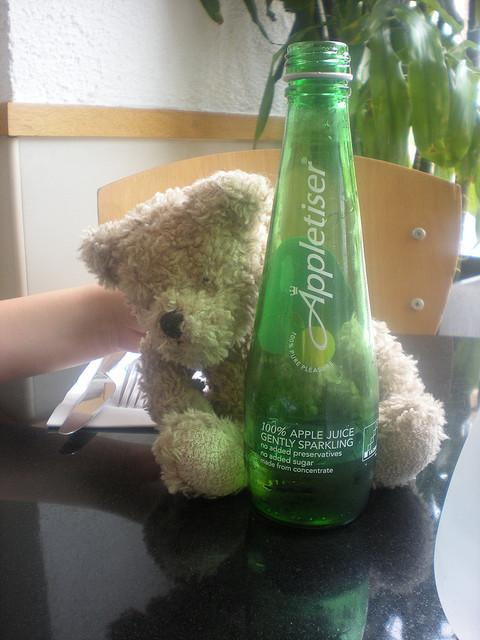What is in the green container? apple juice 